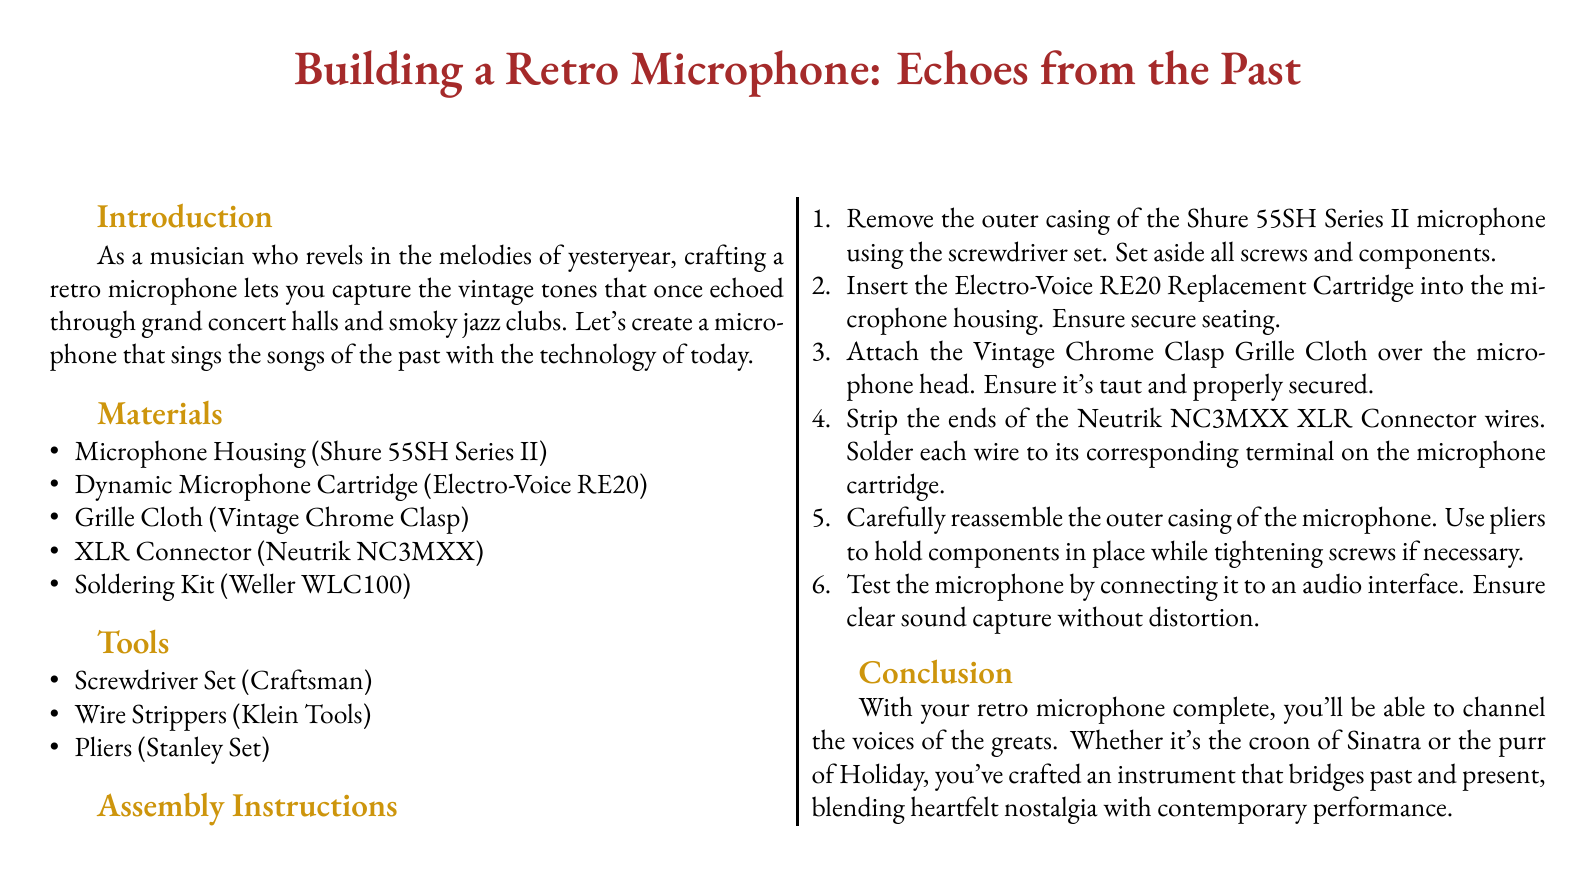What is the title of the document? The title is explicitly mentioned at the start of the document in a large font.
Answer: Building a Retro Microphone: Echoes from the Past Which microphone housing is used? The document specifies the type of microphone housing in the materials section.
Answer: Shure 55SH Series II What is the first step in the assembly instructions? The assembly instructions list the steps in sequential order, with the first step described clearly.
Answer: Remove the outer casing of the Shure 55SH Series II microphone What is the purpose of the soldering kit? The soldering kit is mentioned in the context of preparing connections for the XLR connector.
Answer: To solder wires How many tools are listed in the document? The document contains a list of tools, and the total can be counted directly.
Answer: Three tools What type of cloth is used over the microphone head? The grill cloth type is directly mentioned in the materials section.
Answer: Vintage Chrome Clasp Which component needs to be stripped before soldering? The assembly instructions mention a specific component that requires stripping.
Answer: Neutrik NC3MXX XLR Connector wires What does the completed microphone allow you to channel? The conclusion describes the abilities offered by the finished microphone.
Answer: The voices of the greats What is the color of the page background? The document specifies the color of the background at the beginning of the content.
Answer: White 